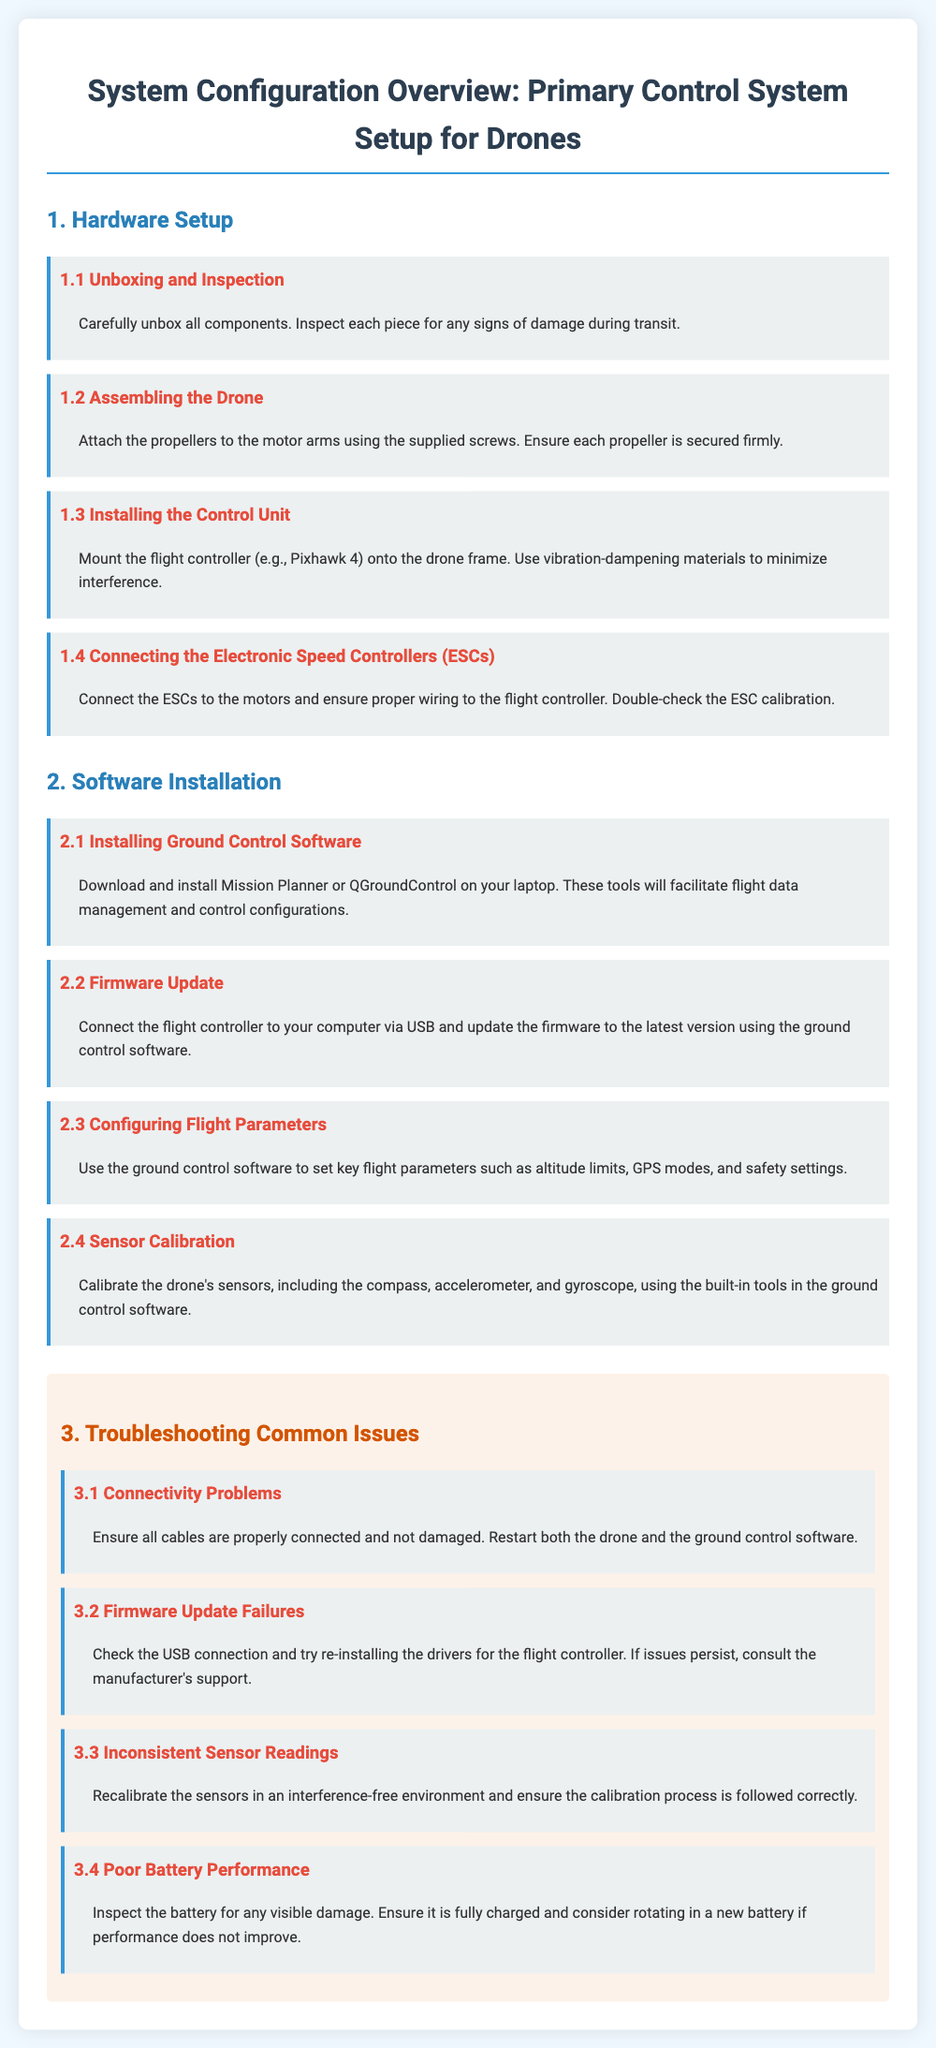What is the first step of the hardware setup? The first step is to carefully unbox all components and inspect each piece for any signs of damage during transit.
Answer: Unboxing and Inspection What does the control unit refer to? The control unit refers to the flight controller, which is to be mounted on the drone frame.
Answer: Flight controller What must be done after installing the ground control software? After installing the ground control software, a firmware update must be performed.
Answer: Firmware update What should be checked if there are connectivity problems? If there are connectivity problems, all cables should be checked for proper connection and damage.
Answer: Cables How should sensors be calibrated? Sensors should be calibrated using the built-in tools in the ground control software.
Answer: Built-in tools What is the consequence of poor battery performance? If battery performance is poor, it may indicate the battery is damaged or not fully charged.
Answer: Battery issues What materials should be used when installing the control unit? Vibration-dampening materials should be used during the installation of the control unit.
Answer: Vibration-dampening materials What software examples are mentioned for ground control? Mission Planner and QGroundControl are mentioned as examples of ground control software.
Answer: Mission Planner, QGroundControl What action is recommended for firmware update failures? It is recommended to check the USB connection and try re-installing the drivers for the flight controller.
Answer: Check USB connection 